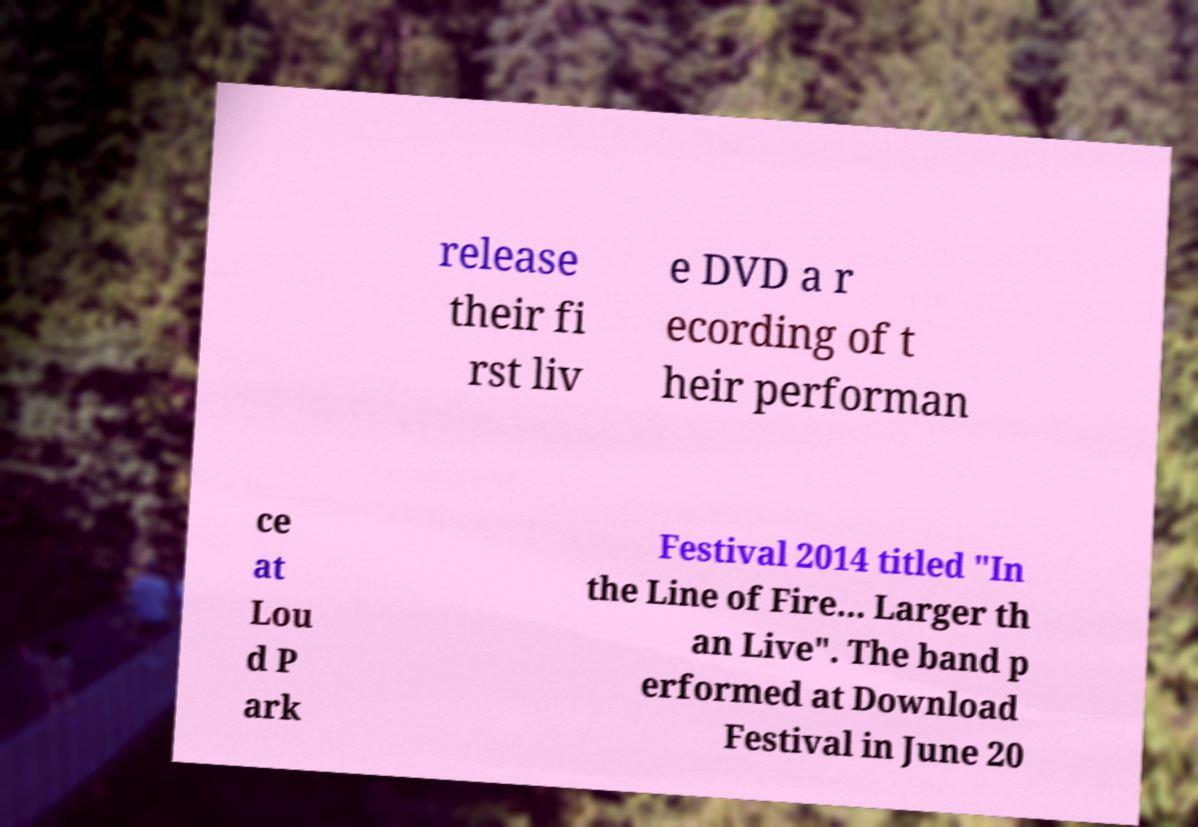Please read and relay the text visible in this image. What does it say? release their fi rst liv e DVD a r ecording of t heir performan ce at Lou d P ark Festival 2014 titled "In the Line of Fire... Larger th an Live". The band p erformed at Download Festival in June 20 